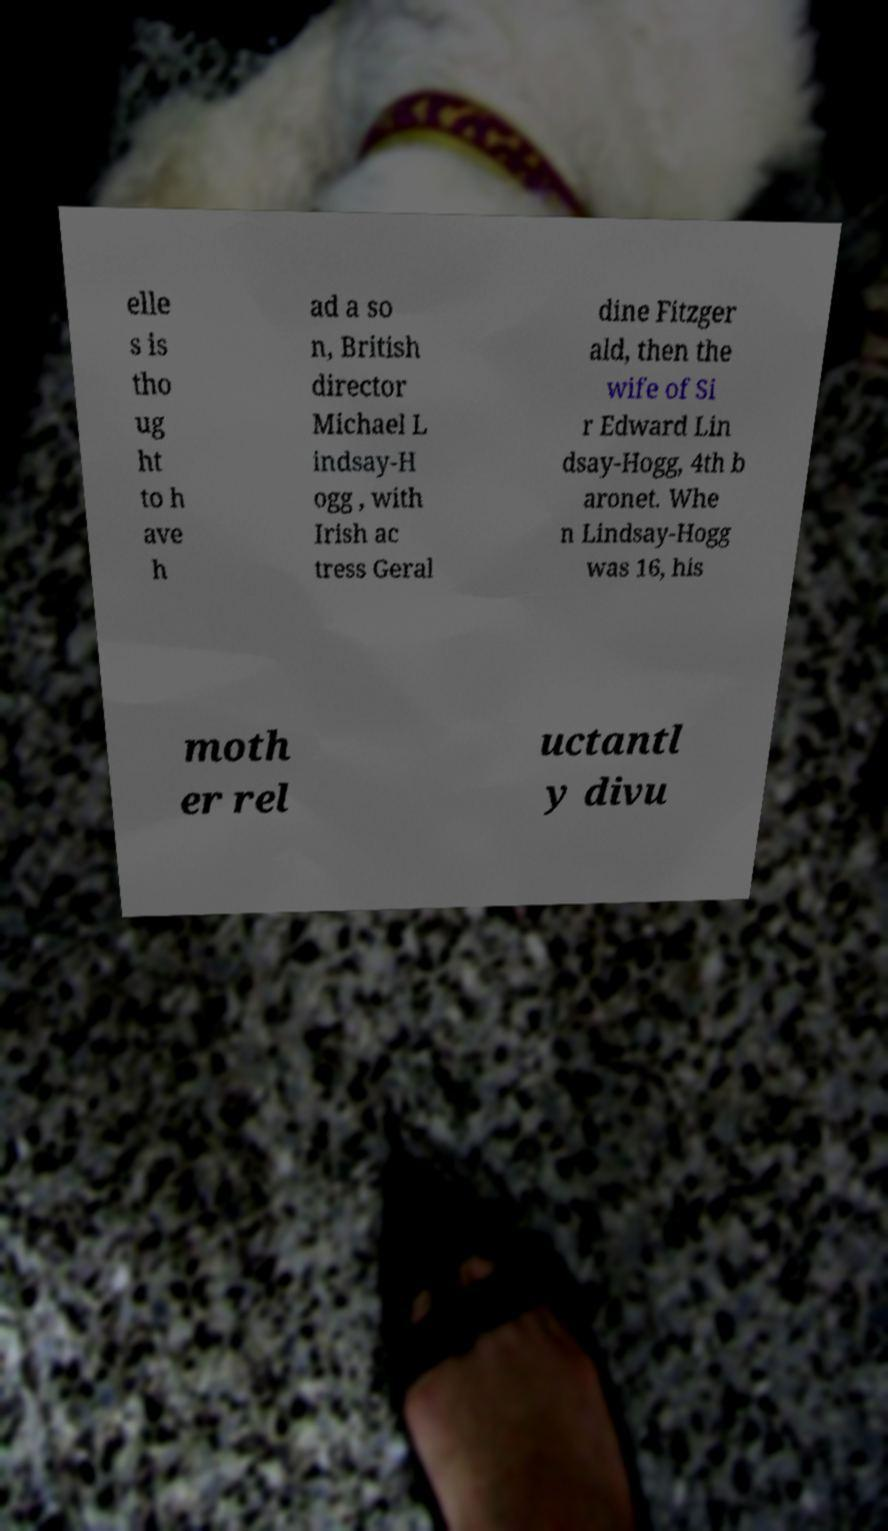There's text embedded in this image that I need extracted. Can you transcribe it verbatim? elle s is tho ug ht to h ave h ad a so n, British director Michael L indsay-H ogg , with Irish ac tress Geral dine Fitzger ald, then the wife of Si r Edward Lin dsay-Hogg, 4th b aronet. Whe n Lindsay-Hogg was 16, his moth er rel uctantl y divu 